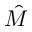Convert formula to latex. <formula><loc_0><loc_0><loc_500><loc_500>\hat { M }</formula> 